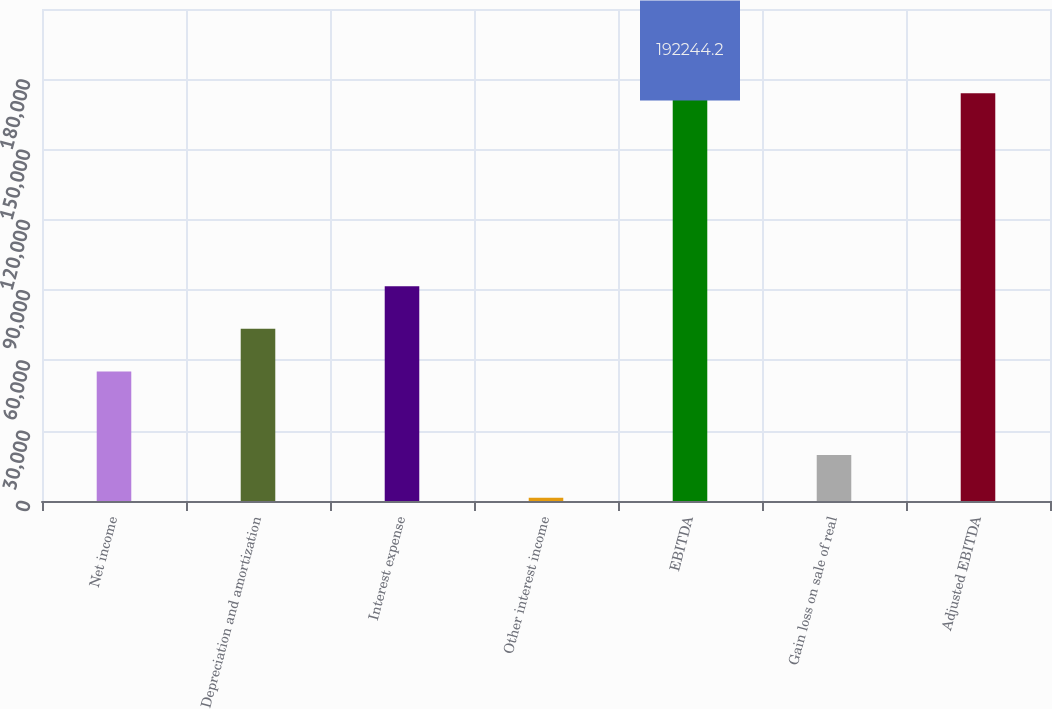Convert chart to OTSL. <chart><loc_0><loc_0><loc_500><loc_500><bar_chart><fcel>Net income<fcel>Depreciation and amortization<fcel>Interest expense<fcel>Other interest income<fcel>EBITDA<fcel>Gain loss on sale of real<fcel>Adjusted EBITDA<nl><fcel>55287<fcel>73497.2<fcel>91707.4<fcel>1386<fcel>192244<fcel>19596.2<fcel>174034<nl></chart> 